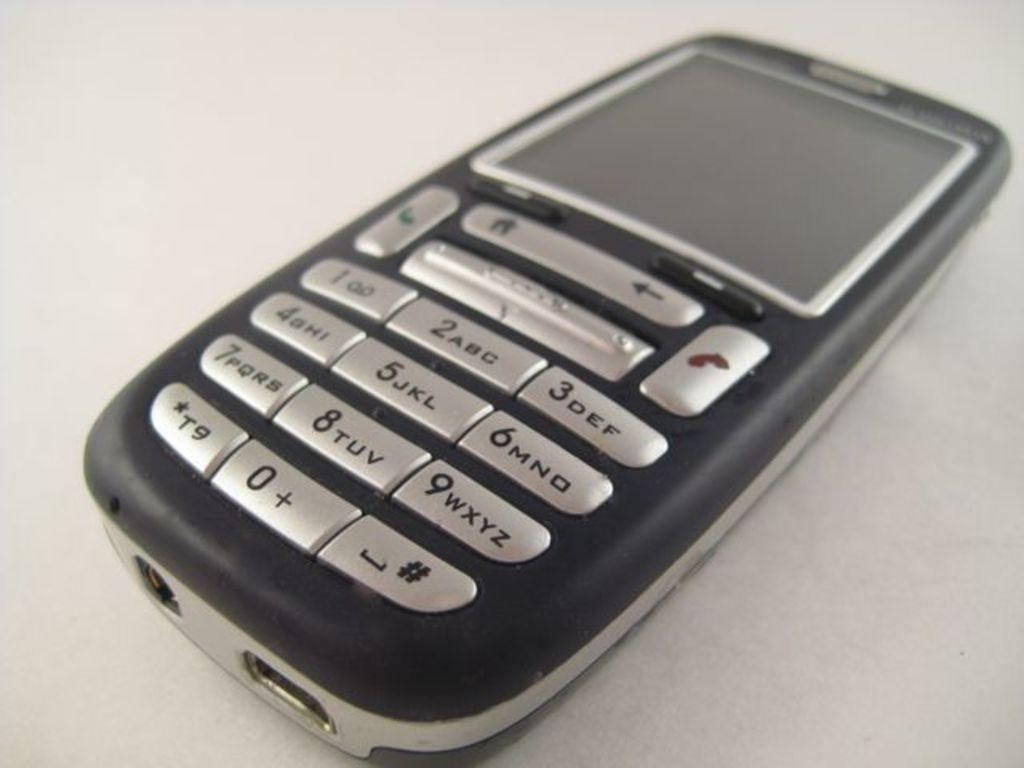<image>
Relay a brief, clear account of the picture shown. A black cell phone says ABC on the number 2 key. 